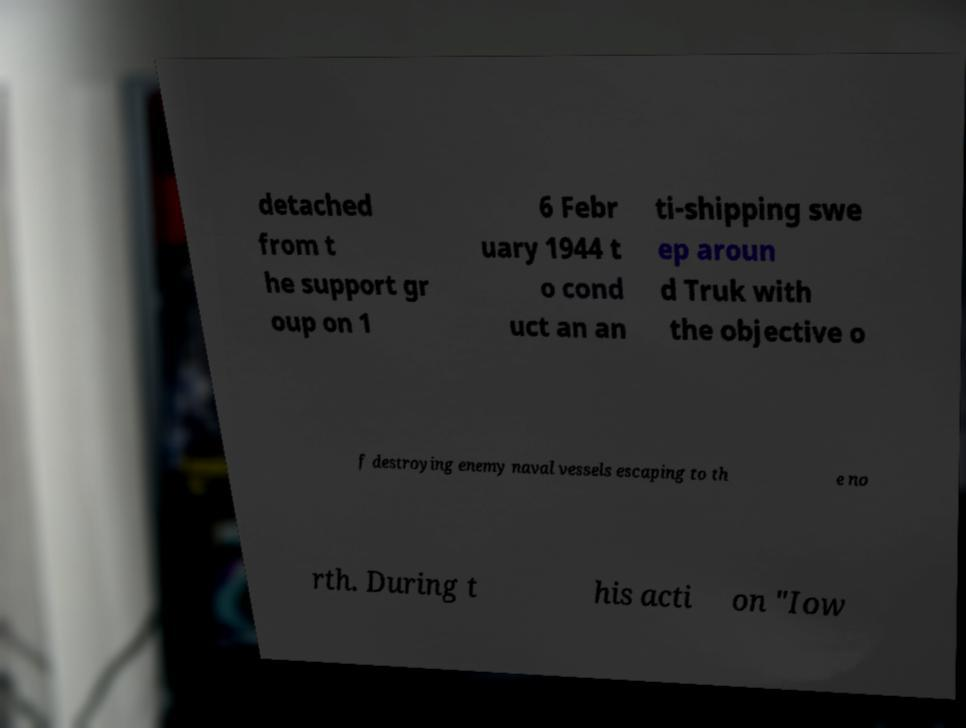There's text embedded in this image that I need extracted. Can you transcribe it verbatim? detached from t he support gr oup on 1 6 Febr uary 1944 t o cond uct an an ti-shipping swe ep aroun d Truk with the objective o f destroying enemy naval vessels escaping to th e no rth. During t his acti on "Iow 